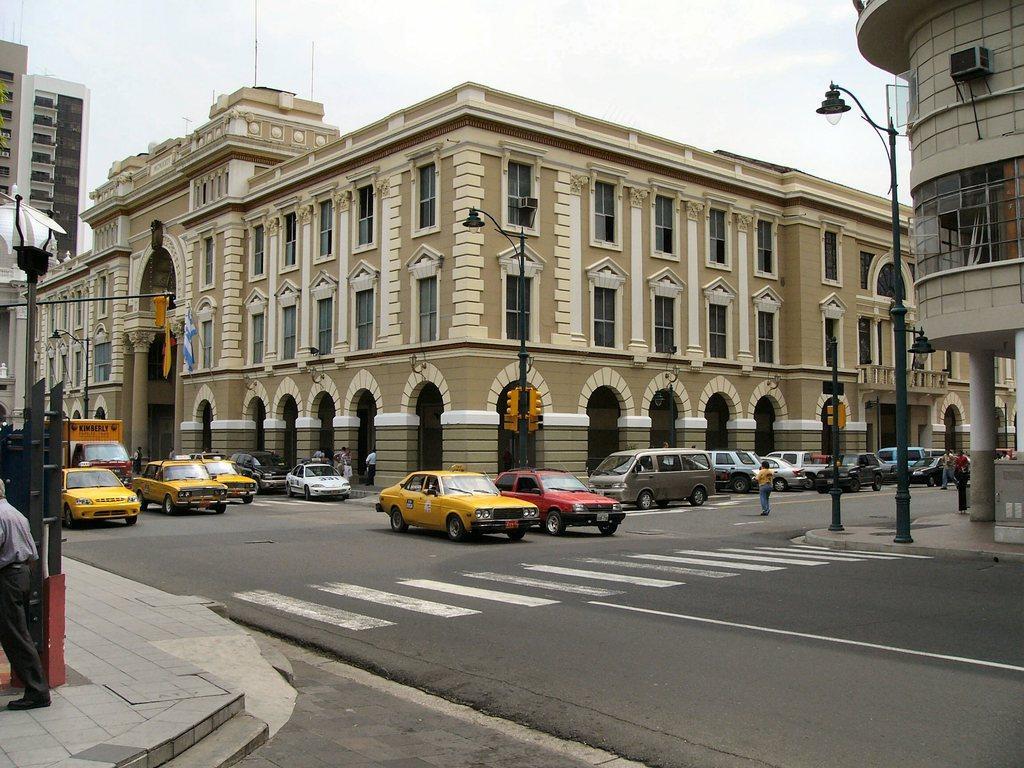Describe this image in one or two sentences. In this image, we can see some cars, buildings and persons. There are street poles beside the road. There is a sky at the top of the image. 